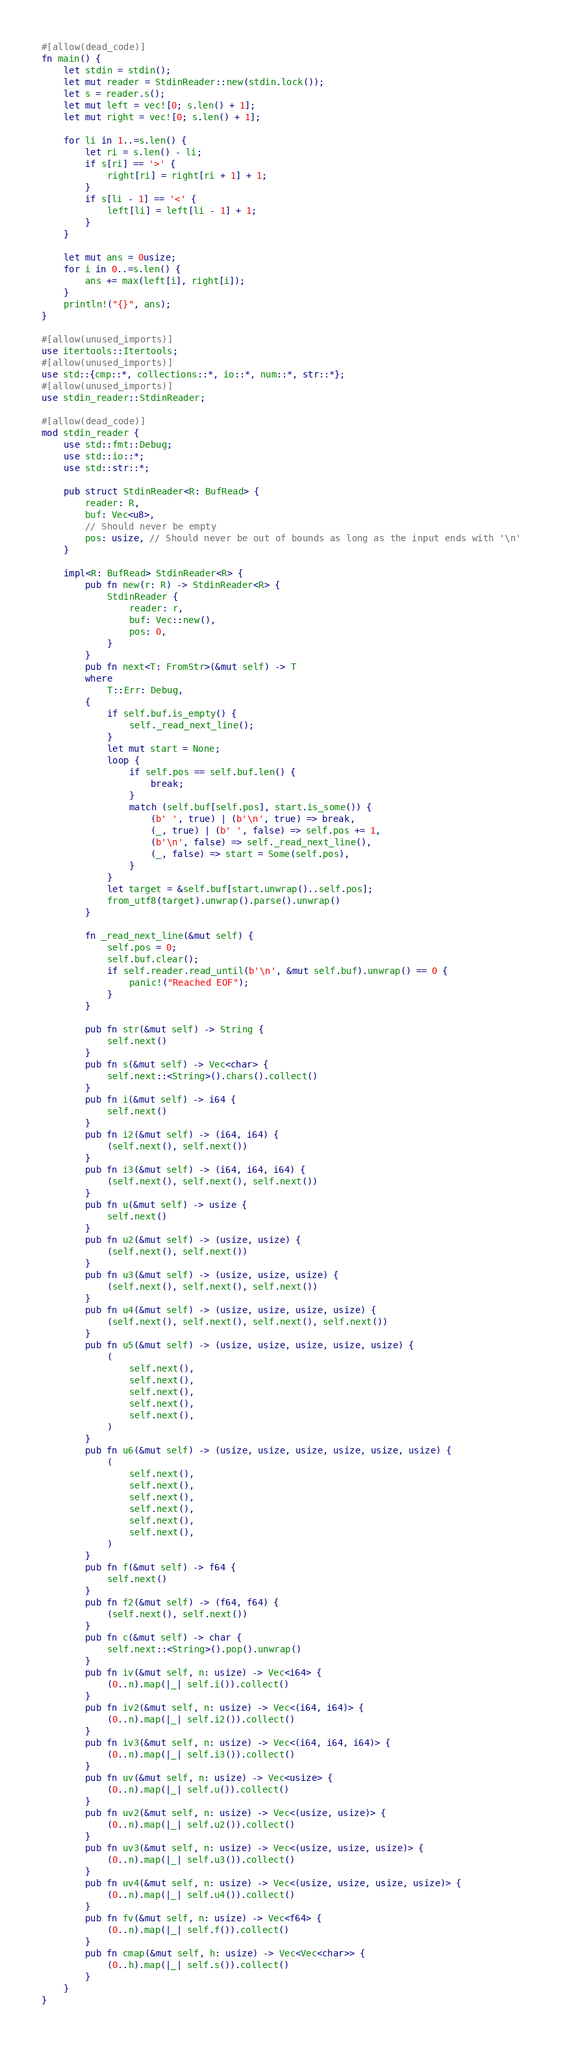<code> <loc_0><loc_0><loc_500><loc_500><_Rust_>#[allow(dead_code)]
fn main() {
    let stdin = stdin();
    let mut reader = StdinReader::new(stdin.lock());
    let s = reader.s();
    let mut left = vec![0; s.len() + 1];
    let mut right = vec![0; s.len() + 1];

    for li in 1..=s.len() {
        let ri = s.len() - li;
        if s[ri] == '>' {
            right[ri] = right[ri + 1] + 1;
        }
        if s[li - 1] == '<' {
            left[li] = left[li - 1] + 1;
        }
    }

    let mut ans = 0usize;
    for i in 0..=s.len() {
        ans += max(left[i], right[i]);
    }
    println!("{}", ans);
}

#[allow(unused_imports)]
use itertools::Itertools;
#[allow(unused_imports)]
use std::{cmp::*, collections::*, io::*, num::*, str::*};
#[allow(unused_imports)]
use stdin_reader::StdinReader;

#[allow(dead_code)]
mod stdin_reader {
    use std::fmt::Debug;
    use std::io::*;
    use std::str::*;

    pub struct StdinReader<R: BufRead> {
        reader: R,
        buf: Vec<u8>,
        // Should never be empty
        pos: usize, // Should never be out of bounds as long as the input ends with '\n'
    }

    impl<R: BufRead> StdinReader<R> {
        pub fn new(r: R) -> StdinReader<R> {
            StdinReader {
                reader: r,
                buf: Vec::new(),
                pos: 0,
            }
        }
        pub fn next<T: FromStr>(&mut self) -> T
        where
            T::Err: Debug,
        {
            if self.buf.is_empty() {
                self._read_next_line();
            }
            let mut start = None;
            loop {
                if self.pos == self.buf.len() {
                    break;
                }
                match (self.buf[self.pos], start.is_some()) {
                    (b' ', true) | (b'\n', true) => break,
                    (_, true) | (b' ', false) => self.pos += 1,
                    (b'\n', false) => self._read_next_line(),
                    (_, false) => start = Some(self.pos),
                }
            }
            let target = &self.buf[start.unwrap()..self.pos];
            from_utf8(target).unwrap().parse().unwrap()
        }

        fn _read_next_line(&mut self) {
            self.pos = 0;
            self.buf.clear();
            if self.reader.read_until(b'\n', &mut self.buf).unwrap() == 0 {
                panic!("Reached EOF");
            }
        }

        pub fn str(&mut self) -> String {
            self.next()
        }
        pub fn s(&mut self) -> Vec<char> {
            self.next::<String>().chars().collect()
        }
        pub fn i(&mut self) -> i64 {
            self.next()
        }
        pub fn i2(&mut self) -> (i64, i64) {
            (self.next(), self.next())
        }
        pub fn i3(&mut self) -> (i64, i64, i64) {
            (self.next(), self.next(), self.next())
        }
        pub fn u(&mut self) -> usize {
            self.next()
        }
        pub fn u2(&mut self) -> (usize, usize) {
            (self.next(), self.next())
        }
        pub fn u3(&mut self) -> (usize, usize, usize) {
            (self.next(), self.next(), self.next())
        }
        pub fn u4(&mut self) -> (usize, usize, usize, usize) {
            (self.next(), self.next(), self.next(), self.next())
        }
        pub fn u5(&mut self) -> (usize, usize, usize, usize, usize) {
            (
                self.next(),
                self.next(),
                self.next(),
                self.next(),
                self.next(),
            )
        }
        pub fn u6(&mut self) -> (usize, usize, usize, usize, usize, usize) {
            (
                self.next(),
                self.next(),
                self.next(),
                self.next(),
                self.next(),
                self.next(),
            )
        }
        pub fn f(&mut self) -> f64 {
            self.next()
        }
        pub fn f2(&mut self) -> (f64, f64) {
            (self.next(), self.next())
        }
        pub fn c(&mut self) -> char {
            self.next::<String>().pop().unwrap()
        }
        pub fn iv(&mut self, n: usize) -> Vec<i64> {
            (0..n).map(|_| self.i()).collect()
        }
        pub fn iv2(&mut self, n: usize) -> Vec<(i64, i64)> {
            (0..n).map(|_| self.i2()).collect()
        }
        pub fn iv3(&mut self, n: usize) -> Vec<(i64, i64, i64)> {
            (0..n).map(|_| self.i3()).collect()
        }
        pub fn uv(&mut self, n: usize) -> Vec<usize> {
            (0..n).map(|_| self.u()).collect()
        }
        pub fn uv2(&mut self, n: usize) -> Vec<(usize, usize)> {
            (0..n).map(|_| self.u2()).collect()
        }
        pub fn uv3(&mut self, n: usize) -> Vec<(usize, usize, usize)> {
            (0..n).map(|_| self.u3()).collect()
        }
        pub fn uv4(&mut self, n: usize) -> Vec<(usize, usize, usize, usize)> {
            (0..n).map(|_| self.u4()).collect()
        }
        pub fn fv(&mut self, n: usize) -> Vec<f64> {
            (0..n).map(|_| self.f()).collect()
        }
        pub fn cmap(&mut self, h: usize) -> Vec<Vec<char>> {
            (0..h).map(|_| self.s()).collect()
        }
    }
}
</code> 